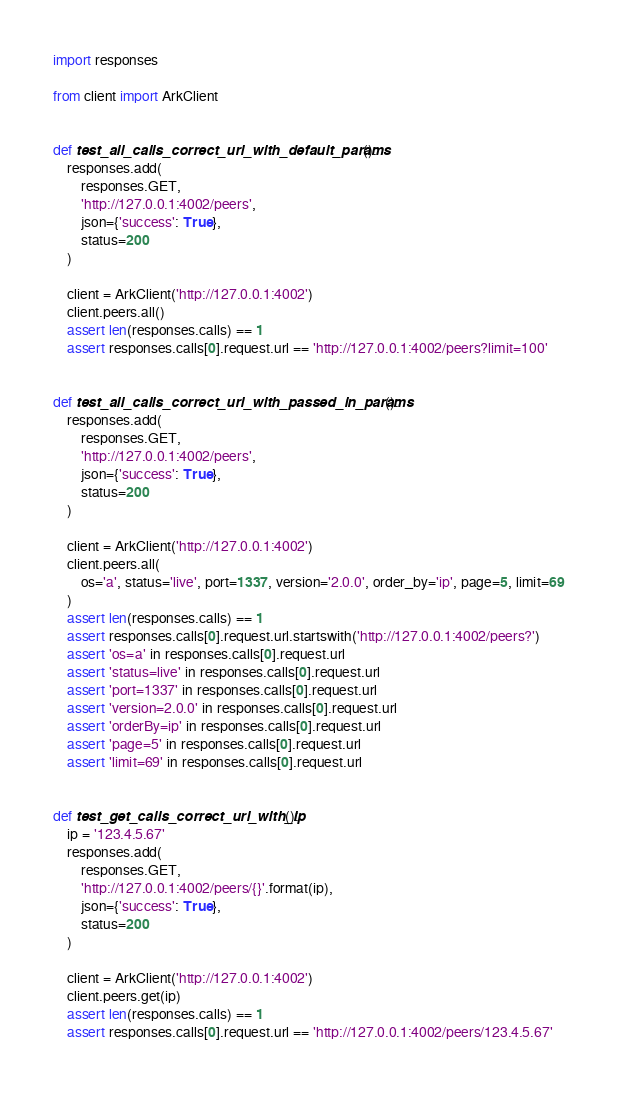Convert code to text. <code><loc_0><loc_0><loc_500><loc_500><_Python_>import responses

from client import ArkClient


def test_all_calls_correct_url_with_default_params():
    responses.add(
        responses.GET,
        'http://127.0.0.1:4002/peers',
        json={'success': True},
        status=200
    )

    client = ArkClient('http://127.0.0.1:4002')
    client.peers.all()
    assert len(responses.calls) == 1
    assert responses.calls[0].request.url == 'http://127.0.0.1:4002/peers?limit=100'


def test_all_calls_correct_url_with_passed_in_params():
    responses.add(
        responses.GET,
        'http://127.0.0.1:4002/peers',
        json={'success': True},
        status=200
    )

    client = ArkClient('http://127.0.0.1:4002')
    client.peers.all(
        os='a', status='live', port=1337, version='2.0.0', order_by='ip', page=5, limit=69
    )
    assert len(responses.calls) == 1
    assert responses.calls[0].request.url.startswith('http://127.0.0.1:4002/peers?')
    assert 'os=a' in responses.calls[0].request.url
    assert 'status=live' in responses.calls[0].request.url
    assert 'port=1337' in responses.calls[0].request.url
    assert 'version=2.0.0' in responses.calls[0].request.url
    assert 'orderBy=ip' in responses.calls[0].request.url
    assert 'page=5' in responses.calls[0].request.url
    assert 'limit=69' in responses.calls[0].request.url


def test_get_calls_correct_url_with_ip():
    ip = '123.4.5.67'
    responses.add(
        responses.GET,
        'http://127.0.0.1:4002/peers/{}'.format(ip),
        json={'success': True},
        status=200
    )

    client = ArkClient('http://127.0.0.1:4002')
    client.peers.get(ip)
    assert len(responses.calls) == 1
    assert responses.calls[0].request.url == 'http://127.0.0.1:4002/peers/123.4.5.67'
</code> 